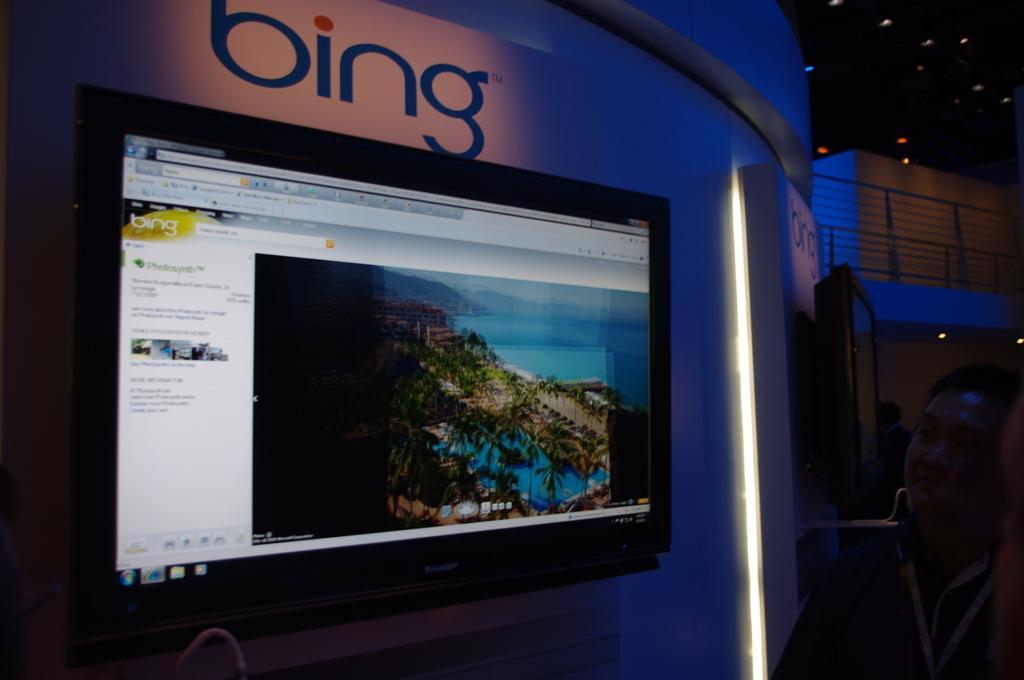Could you give a brief overview of what you see in this image? In the image there is a screen on the wall and on the right side there is a person standing and staring at the screen, there are lights over the ceiling. 